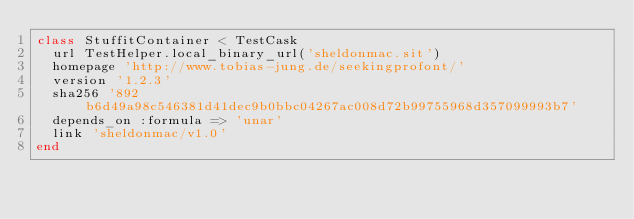Convert code to text. <code><loc_0><loc_0><loc_500><loc_500><_Ruby_>class StuffitContainer < TestCask
  url TestHelper.local_binary_url('sheldonmac.sit')
  homepage 'http://www.tobias-jung.de/seekingprofont/'
  version '1.2.3'
  sha256 '892b6d49a98c546381d41dec9b0bbc04267ac008d72b99755968d357099993b7'
  depends_on :formula => 'unar'
  link 'sheldonmac/v1.0'
end
</code> 